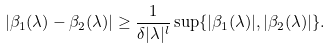<formula> <loc_0><loc_0><loc_500><loc_500>| \beta _ { 1 } ( \lambda ) - \beta _ { 2 } ( \lambda ) | \geq \frac { 1 } { \delta | \lambda | ^ { l } } \sup \{ | \beta _ { 1 } ( \lambda ) | , | \beta _ { 2 } ( \lambda ) | \} .</formula> 